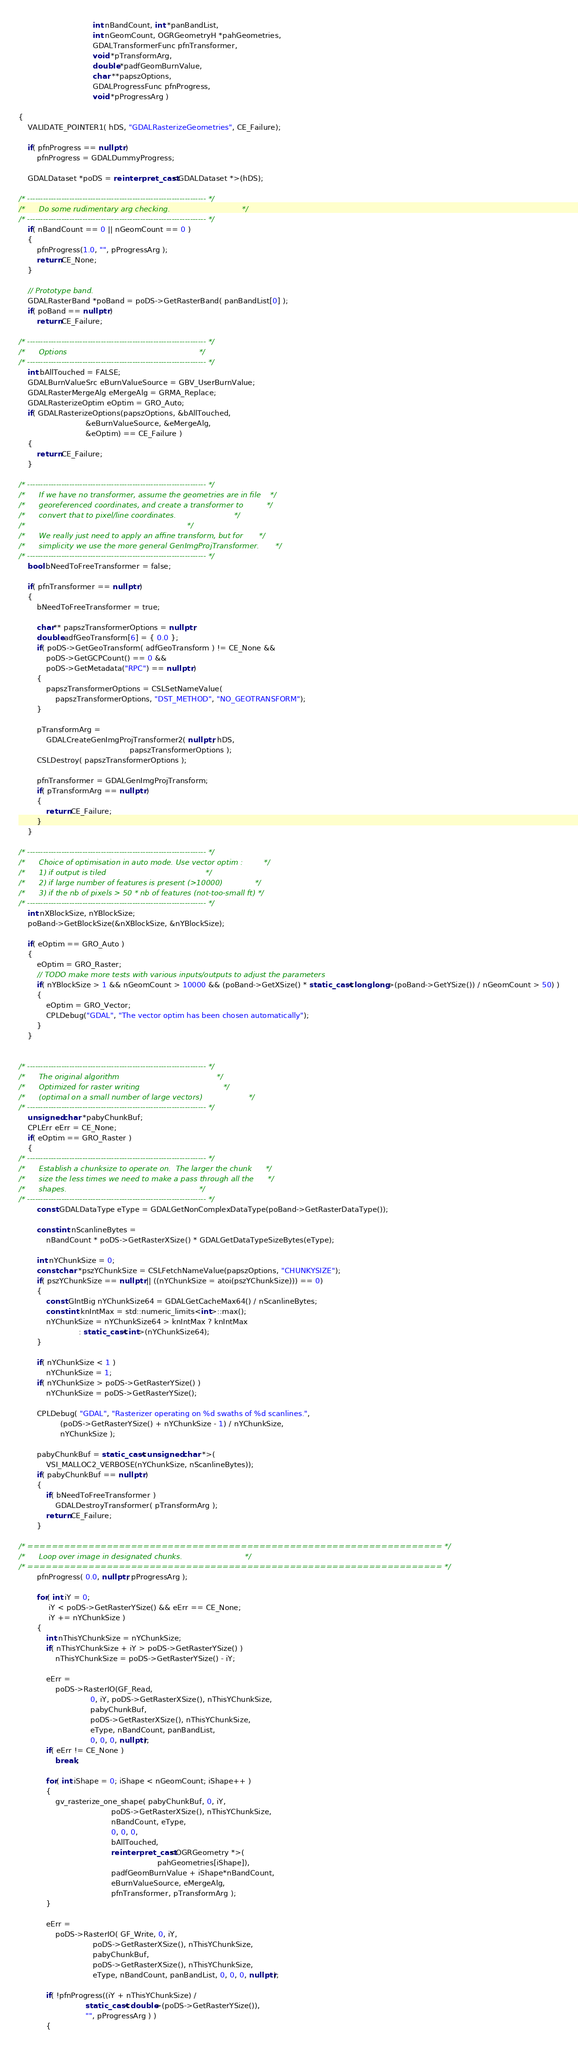<code> <loc_0><loc_0><loc_500><loc_500><_C++_>                                int nBandCount, int *panBandList,
                                int nGeomCount, OGRGeometryH *pahGeometries,
                                GDALTransformerFunc pfnTransformer,
                                void *pTransformArg,
                                double *padfGeomBurnValue,
                                char **papszOptions,
                                GDALProgressFunc pfnProgress,
                                void *pProgressArg )

{
    VALIDATE_POINTER1( hDS, "GDALRasterizeGeometries", CE_Failure);

    if( pfnProgress == nullptr )
        pfnProgress = GDALDummyProgress;

    GDALDataset *poDS = reinterpret_cast<GDALDataset *>(hDS);

/* -------------------------------------------------------------------- */
/*      Do some rudimentary arg checking.                               */
/* -------------------------------------------------------------------- */
    if( nBandCount == 0 || nGeomCount == 0 )
    {
        pfnProgress(1.0, "", pProgressArg );
        return CE_None;
    }

    // Prototype band.
    GDALRasterBand *poBand = poDS->GetRasterBand( panBandList[0] );
    if( poBand == nullptr )
        return CE_Failure;

/* -------------------------------------------------------------------- */
/*      Options                                                         */
/* -------------------------------------------------------------------- */
    int bAllTouched = FALSE;
    GDALBurnValueSrc eBurnValueSource = GBV_UserBurnValue;
    GDALRasterMergeAlg eMergeAlg = GRMA_Replace;
    GDALRasterizeOptim eOptim = GRO_Auto;
    if( GDALRasterizeOptions(papszOptions, &bAllTouched,
                             &eBurnValueSource, &eMergeAlg,
                             &eOptim) == CE_Failure )
    {
        return CE_Failure;
    }

/* -------------------------------------------------------------------- */
/*      If we have no transformer, assume the geometries are in file    */
/*      georeferenced coordinates, and create a transformer to          */
/*      convert that to pixel/line coordinates.                         */
/*                                                                      */
/*      We really just need to apply an affine transform, but for       */
/*      simplicity we use the more general GenImgProjTransformer.       */
/* -------------------------------------------------------------------- */
    bool bNeedToFreeTransformer = false;

    if( pfnTransformer == nullptr )
    {
        bNeedToFreeTransformer = true;

        char** papszTransformerOptions = nullptr;
        double adfGeoTransform[6] = { 0.0 };
        if( poDS->GetGeoTransform( adfGeoTransform ) != CE_None &&
            poDS->GetGCPCount() == 0 &&
            poDS->GetMetadata("RPC") == nullptr )
        {
            papszTransformerOptions = CSLSetNameValue(
                papszTransformerOptions, "DST_METHOD", "NO_GEOTRANSFORM");
        }

        pTransformArg =
            GDALCreateGenImgProjTransformer2( nullptr, hDS,
                                                papszTransformerOptions );
        CSLDestroy( papszTransformerOptions );

        pfnTransformer = GDALGenImgProjTransform;
        if( pTransformArg == nullptr )
        {
            return CE_Failure;
        }
    }

/* -------------------------------------------------------------------- */
/*      Choice of optimisation in auto mode. Use vector optim :         */
/*      1) if output is tiled                                           */
/*      2) if large number of features is present (>10000)              */
/*      3) if the nb of pixels > 50 * nb of features (not-too-small ft) */
/* -------------------------------------------------------------------- */
    int nXBlockSize, nYBlockSize;
    poBand->GetBlockSize(&nXBlockSize, &nYBlockSize);

    if( eOptim == GRO_Auto )
    {
        eOptim = GRO_Raster;
        // TODO make more tests with various inputs/outputs to adjust the parameters
        if( nYBlockSize > 1 && nGeomCount > 10000 && (poBand->GetXSize() * static_cast<long long>(poBand->GetYSize()) / nGeomCount > 50) )
        {
            eOptim = GRO_Vector;
            CPLDebug("GDAL", "The vector optim has been chosen automatically");
        }
    }


/* -------------------------------------------------------------------- */
/*      The original algorithm                                          */
/*      Optimized for raster writing                                    */
/*      (optimal on a small number of large vectors)                    */
/* -------------------------------------------------------------------- */
    unsigned char *pabyChunkBuf;
    CPLErr eErr = CE_None;
    if( eOptim == GRO_Raster )
    {
/* -------------------------------------------------------------------- */
/*      Establish a chunksize to operate on.  The larger the chunk      */
/*      size the less times we need to make a pass through all the      */
/*      shapes.                                                         */
/* -------------------------------------------------------------------- */
        const GDALDataType eType = GDALGetNonComplexDataType(poBand->GetRasterDataType());

        const int nScanlineBytes =
            nBandCount * poDS->GetRasterXSize() * GDALGetDataTypeSizeBytes(eType);

        int nYChunkSize = 0;
        const char *pszYChunkSize = CSLFetchNameValue(papszOptions, "CHUNKYSIZE");
        if( pszYChunkSize == nullptr || ((nYChunkSize = atoi(pszYChunkSize))) == 0)
        {
            const GIntBig nYChunkSize64 = GDALGetCacheMax64() / nScanlineBytes;
            const int knIntMax = std::numeric_limits<int>::max();
            nYChunkSize = nYChunkSize64 > knIntMax ? knIntMax
                          : static_cast<int>(nYChunkSize64);
        }

        if( nYChunkSize < 1 )
            nYChunkSize = 1;
        if( nYChunkSize > poDS->GetRasterYSize() )
            nYChunkSize = poDS->GetRasterYSize();

        CPLDebug( "GDAL", "Rasterizer operating on %d swaths of %d scanlines.",
                  (poDS->GetRasterYSize() + nYChunkSize - 1) / nYChunkSize,
                  nYChunkSize );

        pabyChunkBuf = static_cast<unsigned char *>(
            VSI_MALLOC2_VERBOSE(nYChunkSize, nScanlineBytes));
        if( pabyChunkBuf == nullptr )
        {
            if( bNeedToFreeTransformer )
                GDALDestroyTransformer( pTransformArg );
            return CE_Failure;
        }

/* ==================================================================== */
/*      Loop over image in designated chunks.                           */
/* ==================================================================== */
        pfnProgress( 0.0, nullptr, pProgressArg );

        for( int iY = 0;
             iY < poDS->GetRasterYSize() && eErr == CE_None;
             iY += nYChunkSize )
        {
            int nThisYChunkSize = nYChunkSize;
            if( nThisYChunkSize + iY > poDS->GetRasterYSize() )
                nThisYChunkSize = poDS->GetRasterYSize() - iY;

            eErr =
                poDS->RasterIO(GF_Read,
                               0, iY, poDS->GetRasterXSize(), nThisYChunkSize,
                               pabyChunkBuf,
                               poDS->GetRasterXSize(), nThisYChunkSize,
                               eType, nBandCount, panBandList,
                               0, 0, 0, nullptr);
            if( eErr != CE_None )
                break;

            for( int iShape = 0; iShape < nGeomCount; iShape++ )
            {
                gv_rasterize_one_shape( pabyChunkBuf, 0, iY,
                                        poDS->GetRasterXSize(), nThisYChunkSize,
                                        nBandCount, eType,
                                        0, 0, 0,
                                        bAllTouched,
                                        reinterpret_cast<OGRGeometry *>(
                                                            pahGeometries[iShape]),
                                        padfGeomBurnValue + iShape*nBandCount,
                                        eBurnValueSource, eMergeAlg,
                                        pfnTransformer, pTransformArg );
            }

            eErr =
                poDS->RasterIO( GF_Write, 0, iY,
                                poDS->GetRasterXSize(), nThisYChunkSize,
                                pabyChunkBuf,
                                poDS->GetRasterXSize(), nThisYChunkSize,
                                eType, nBandCount, panBandList, 0, 0, 0, nullptr);

            if( !pfnProgress((iY + nThisYChunkSize) /
                             static_cast<double>(poDS->GetRasterYSize()),
                             "", pProgressArg ) )
            {</code> 